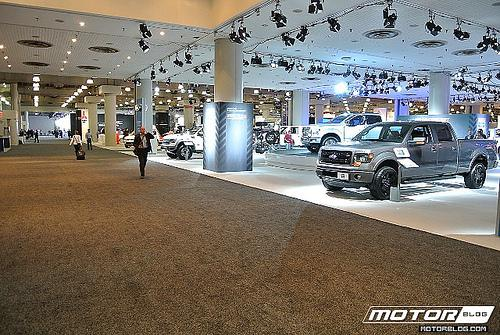Question: what type of vehicle is in the picture?
Choices:
A. Car.
B. Boat.
C. Truck.
D. Suv.
Answer with the letter. Answer: C Question: who is closest to the camera?
Choices:
A. The woman.
B. The girl.
C. A man.
D. The boy.
Answer with the letter. Answer: C Question: what is in the bottom right corner of the photo?
Choices:
A. A signature.
B. The author.
C. A motor blog logo.
D. The logo.
Answer with the letter. Answer: C 